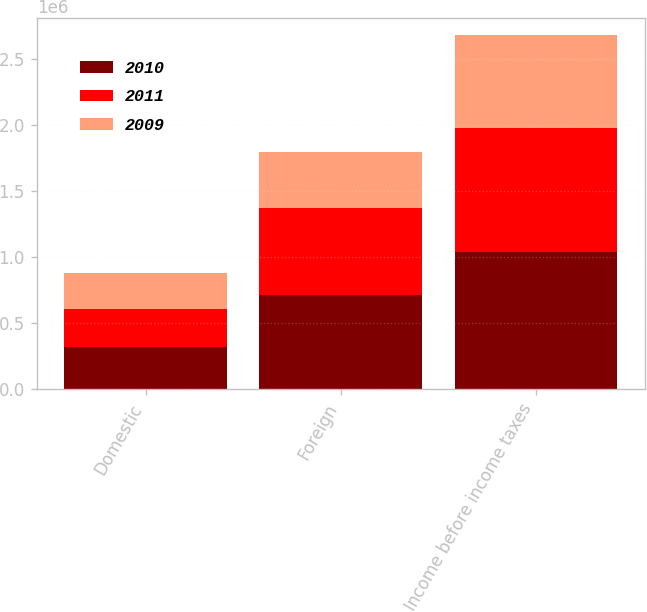Convert chart to OTSL. <chart><loc_0><loc_0><loc_500><loc_500><stacked_bar_chart><ecel><fcel>Domestic<fcel>Foreign<fcel>Income before income taxes<nl><fcel>2010<fcel>319500<fcel>715730<fcel>1.03523e+06<nl><fcel>2011<fcel>283819<fcel>659332<fcel>943151<nl><fcel>2009<fcel>279095<fcel>422425<fcel>701520<nl></chart> 